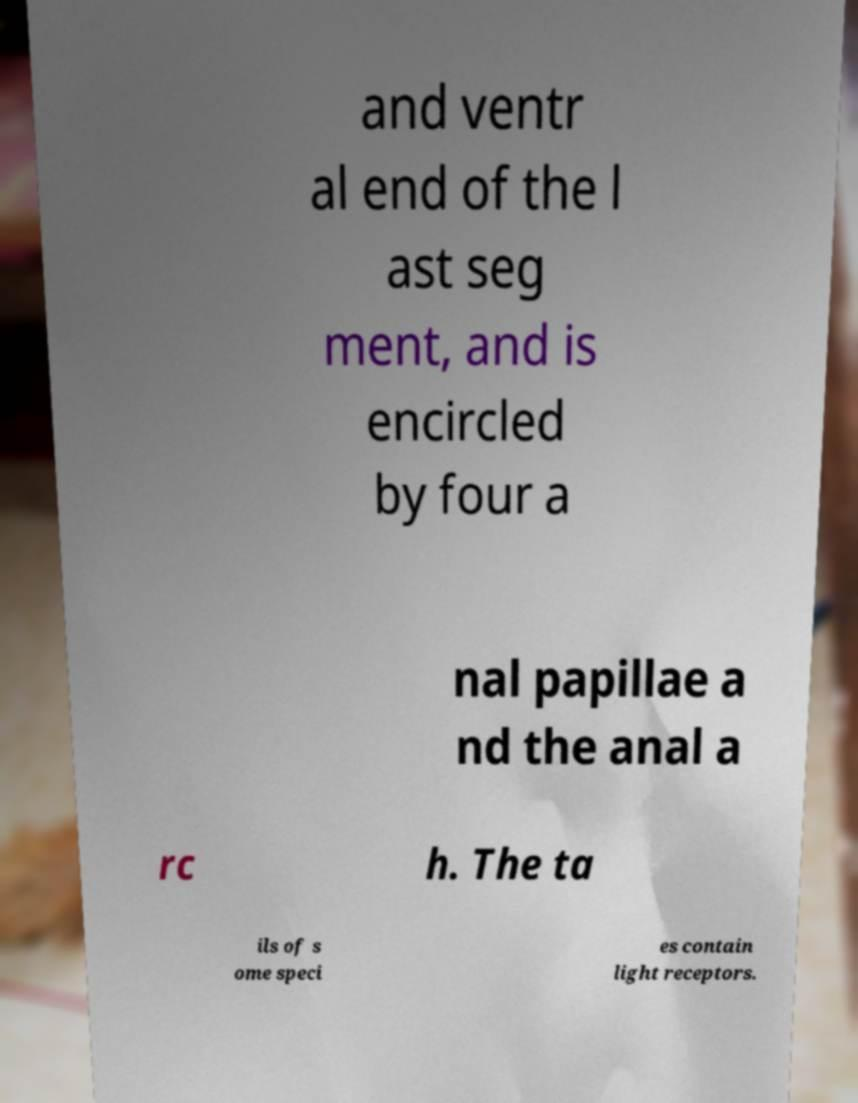Please read and relay the text visible in this image. What does it say? and ventr al end of the l ast seg ment, and is encircled by four a nal papillae a nd the anal a rc h. The ta ils of s ome speci es contain light receptors. 